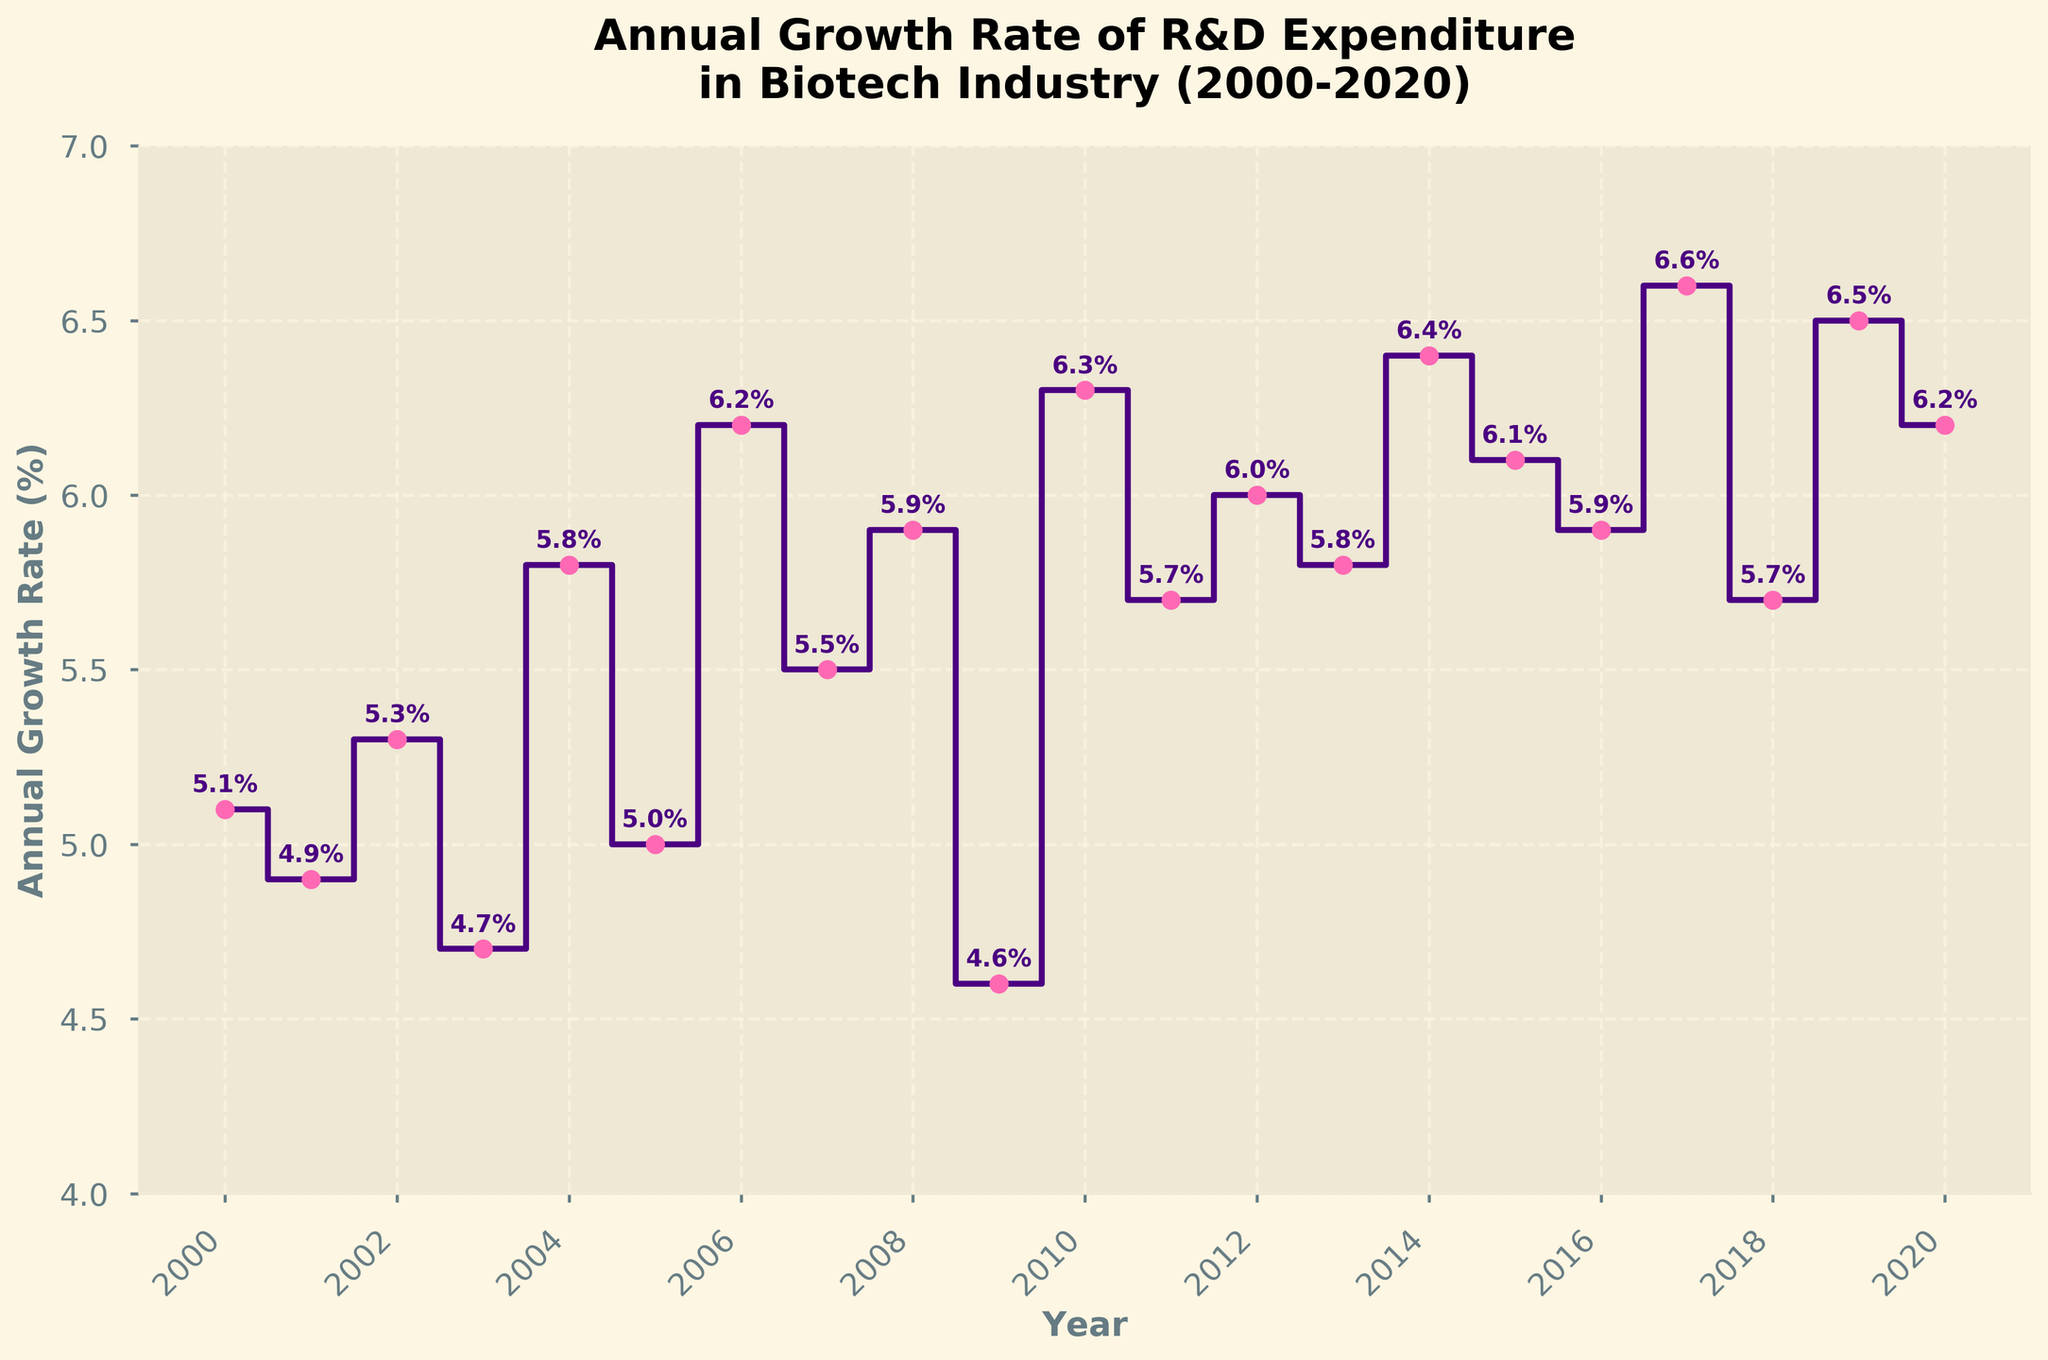What's the title of the figure? The title of the figure is located at the top and reads "Annual Growth Rate of R&D Expenditure\nin Biotech Industry (2000-2020)."
Answer: Annual Growth Rate of R&D Expenditure\nin Biotech Industry (2000-2020) Which year has the highest annual growth rate in the given period? By looking at the growth rates, the highest value is 6.6%, which occurred in the year 2017.
Answer: 2017 How does the growth rate in 2015 compare to the growth rate in 2009? The growth rate in 2015 is 6.1% while the growth rate in 2009 is 4.6%. The growth rate in 2015 is higher by 1.5 percentage points.
Answer: Growth rate in 2015 is higher What's the average annual growth rate of R&D expenditure from 2000 to 2020? To calculate the average, sum all the annual growth rates and divide by the number of years: (5.1 + 4.9 + 5.3 + 4.7 + 5.8 + 5.0 + 6.2 + 5.5 + 5.9 + 4.6 + 6.3 + 5.7 + 6.0 + 5.8 + 6.4 + 6.1 + 5.9 + 6.6 + 5.7 + 6.5 + 6.2) / 21 = 5.73%
Answer: 5.73% How many years have an annual growth rate equal to or above 6%? By reviewing the data points, years with growth rates of 6% or above are 2006, 2010, 2012, 2014, 2015, 2017, 2019, 2020. That's a total of 8 years.
Answer: 8 years In which year did the annual growth rate drop the most compared to the previous year? The most significant drop is from 2010 to 2011, where the growth rate fell from 6.3% to 5.7%, which is a drop of 0.6 percentage points.
Answer: 2011 What is the range of annual growth rates observed from 2000 to 2020? The range is calculated by finding the difference between the highest and lowest values. The highest value is 6.6% (2017), and the lowest is 4.6% (2009). The range is 6.6% - 4.6% = 2.0%.
Answer: 2.0% Which two consecutive years had the closest annual growth rates? The closest growth rates occur between 2001 and 2002, where the rates are 4.9% and 5.3%, respectively, resulting in a difference of 0.4 percentage points.
Answer: 2001-2002 What trend can be observed in the annual growth rate of R&D expenditure from 2000 to 2020? There are fluctuations in the annual growth rates, but overall, there seems to be a trend of gradual increase with some noticeable dips in certain years like 2003, 2009, and 2011.
Answer: Gradual increase with fluctuations What was the growth rate trend during the mid-2010s (2013-2017)? Between 2013 and 2017, the growth rates showed an increasing trend, starting from 5.8% in 2013 to 6.6% in 2017.
Answer: Increasing trend 